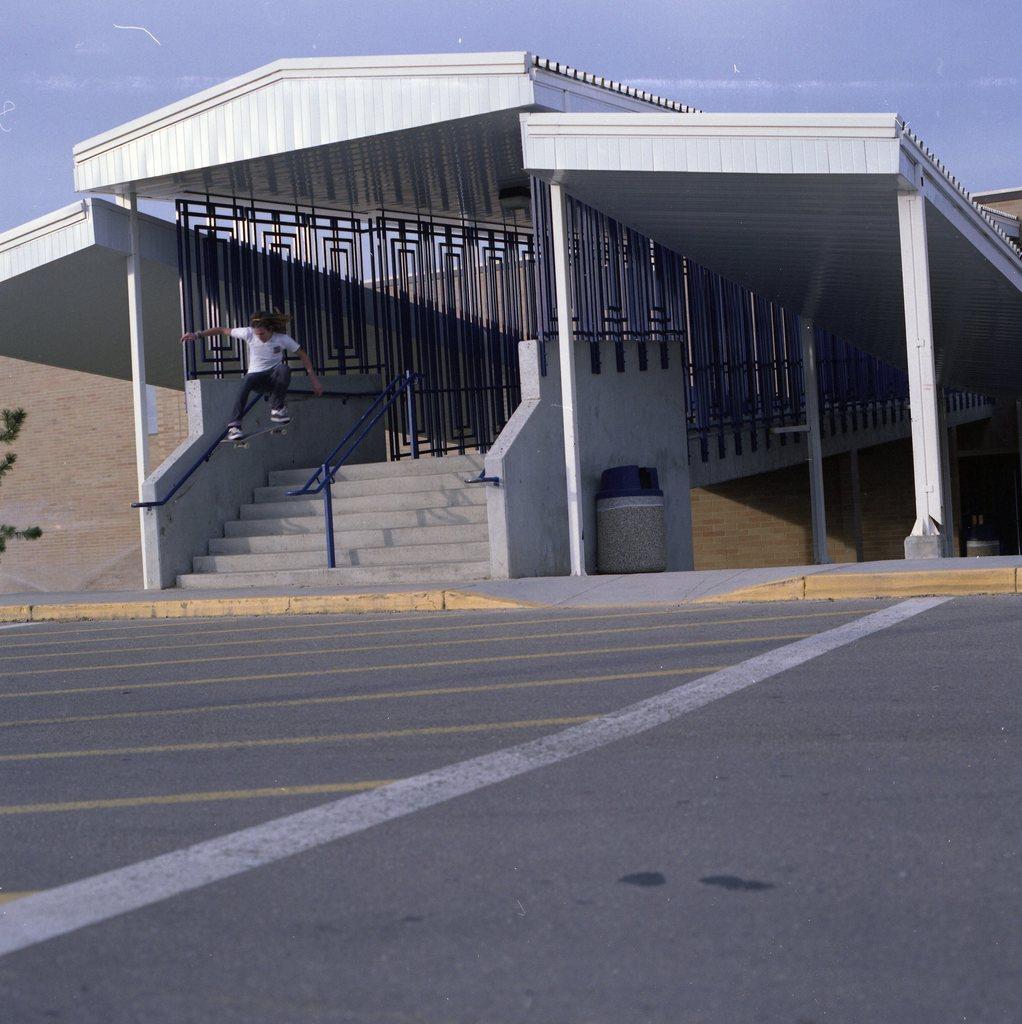Can you describe this image briefly? At the top there is a sky. Here we can see open shed with railing. This is a trash can near to a wall. Here we can see a person with a skateboard in the air. This is a road. 